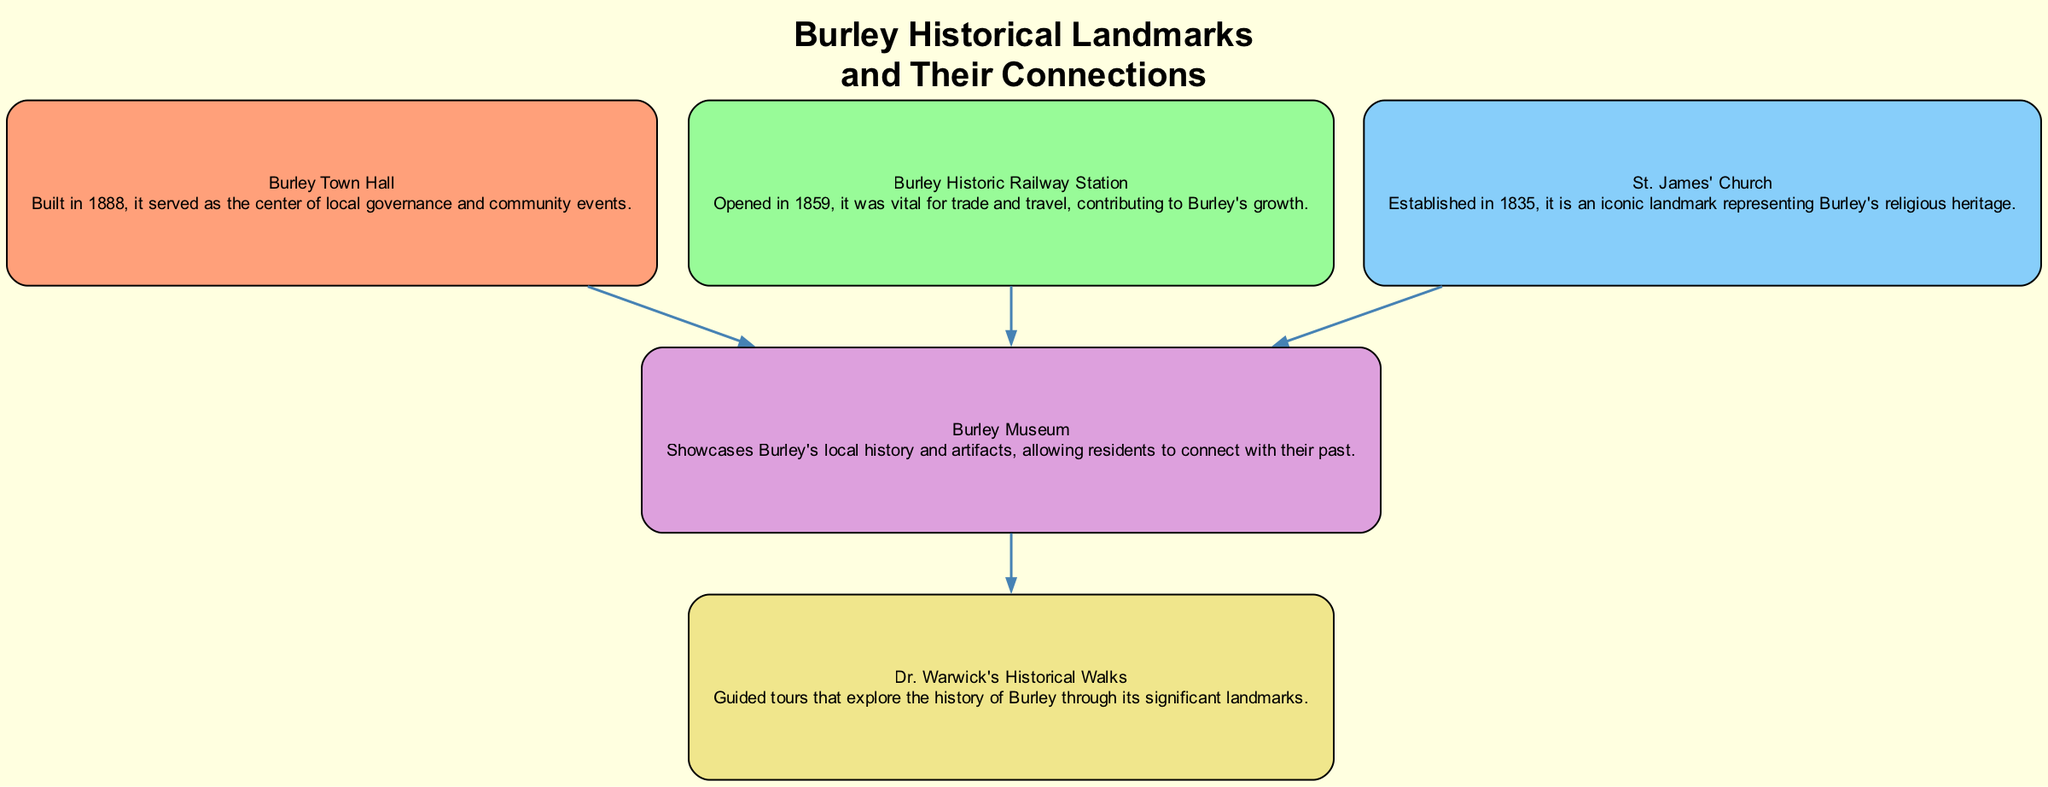What is the total number of landmarks shown in the diagram? The diagram contains five nodes representing historical landmarks. Each node corresponds to a unique landmark in Burley, so we count them to get the total.
Answer: 5 Which landmark was built in 1888? We look at the nodes to find out which one specifically mentions the year 1888. Upon inspection, "Burley Town Hall" is built in that year, making it the correct answer.
Answer: Burley Town Hall What iconic landmark represents Burley's religious heritage? By examining the nodes, the description for "St. James' Church" clearly states that it represents Burley's religious heritage. Thus, it is the answer to this question.
Answer: St. James' Church How many edges connect the Burley Museum to other landmarks? To determine the number of connections, we check the edges linked to "Burley Museum." There are three incoming edges from "Burley Town Hall," "Burley Historic Railway Station," and "St. James' Church," and one outgoing edge to "Warwick Historical Walks." This sums to four edges.
Answer: 4 Which landmark is associated with guided tours exploring Burley's history? The description for "Dr. Warwick's Historical Walks" mentions guided tours exploring Burley, indicating it's the landmark associated with such tours.
Answer: Dr. Warwick's Historical Walks What connects all three of the following landmarks: Burley Town Hall, Burley Historic Railway Station, and St. James' Church? All three landmarks have direct edges pointing to "Burley Museum," indicating they are all connected to it. Therefore, Burley Museum is the linking node.
Answer: Burley Museum Which landmark opened in 1859? The node labelled "Burley Historic Railway Station" indicates that it opened in 1859, making it the answer to this question.
Answer: Burley Historic Railway Station How many landmarks have direct connections to the Burley Museum? Analyzing the edges, we see that there are three landmarks with incoming edges connecting them to "Burley Museum" (Burley Town Hall, Burley Historic Railway Station, and St. James' Church). This number gives us the answer.
Answer: 3 What is the relationship between Burley Museum and Dr. Warwick's Historical Walks? The diagram shows a directed edge going from "Burley Museum" to "Warwick Historical Walks," indicating that the museum has a direct connection to the guided tours offered.
Answer: Directed edge 